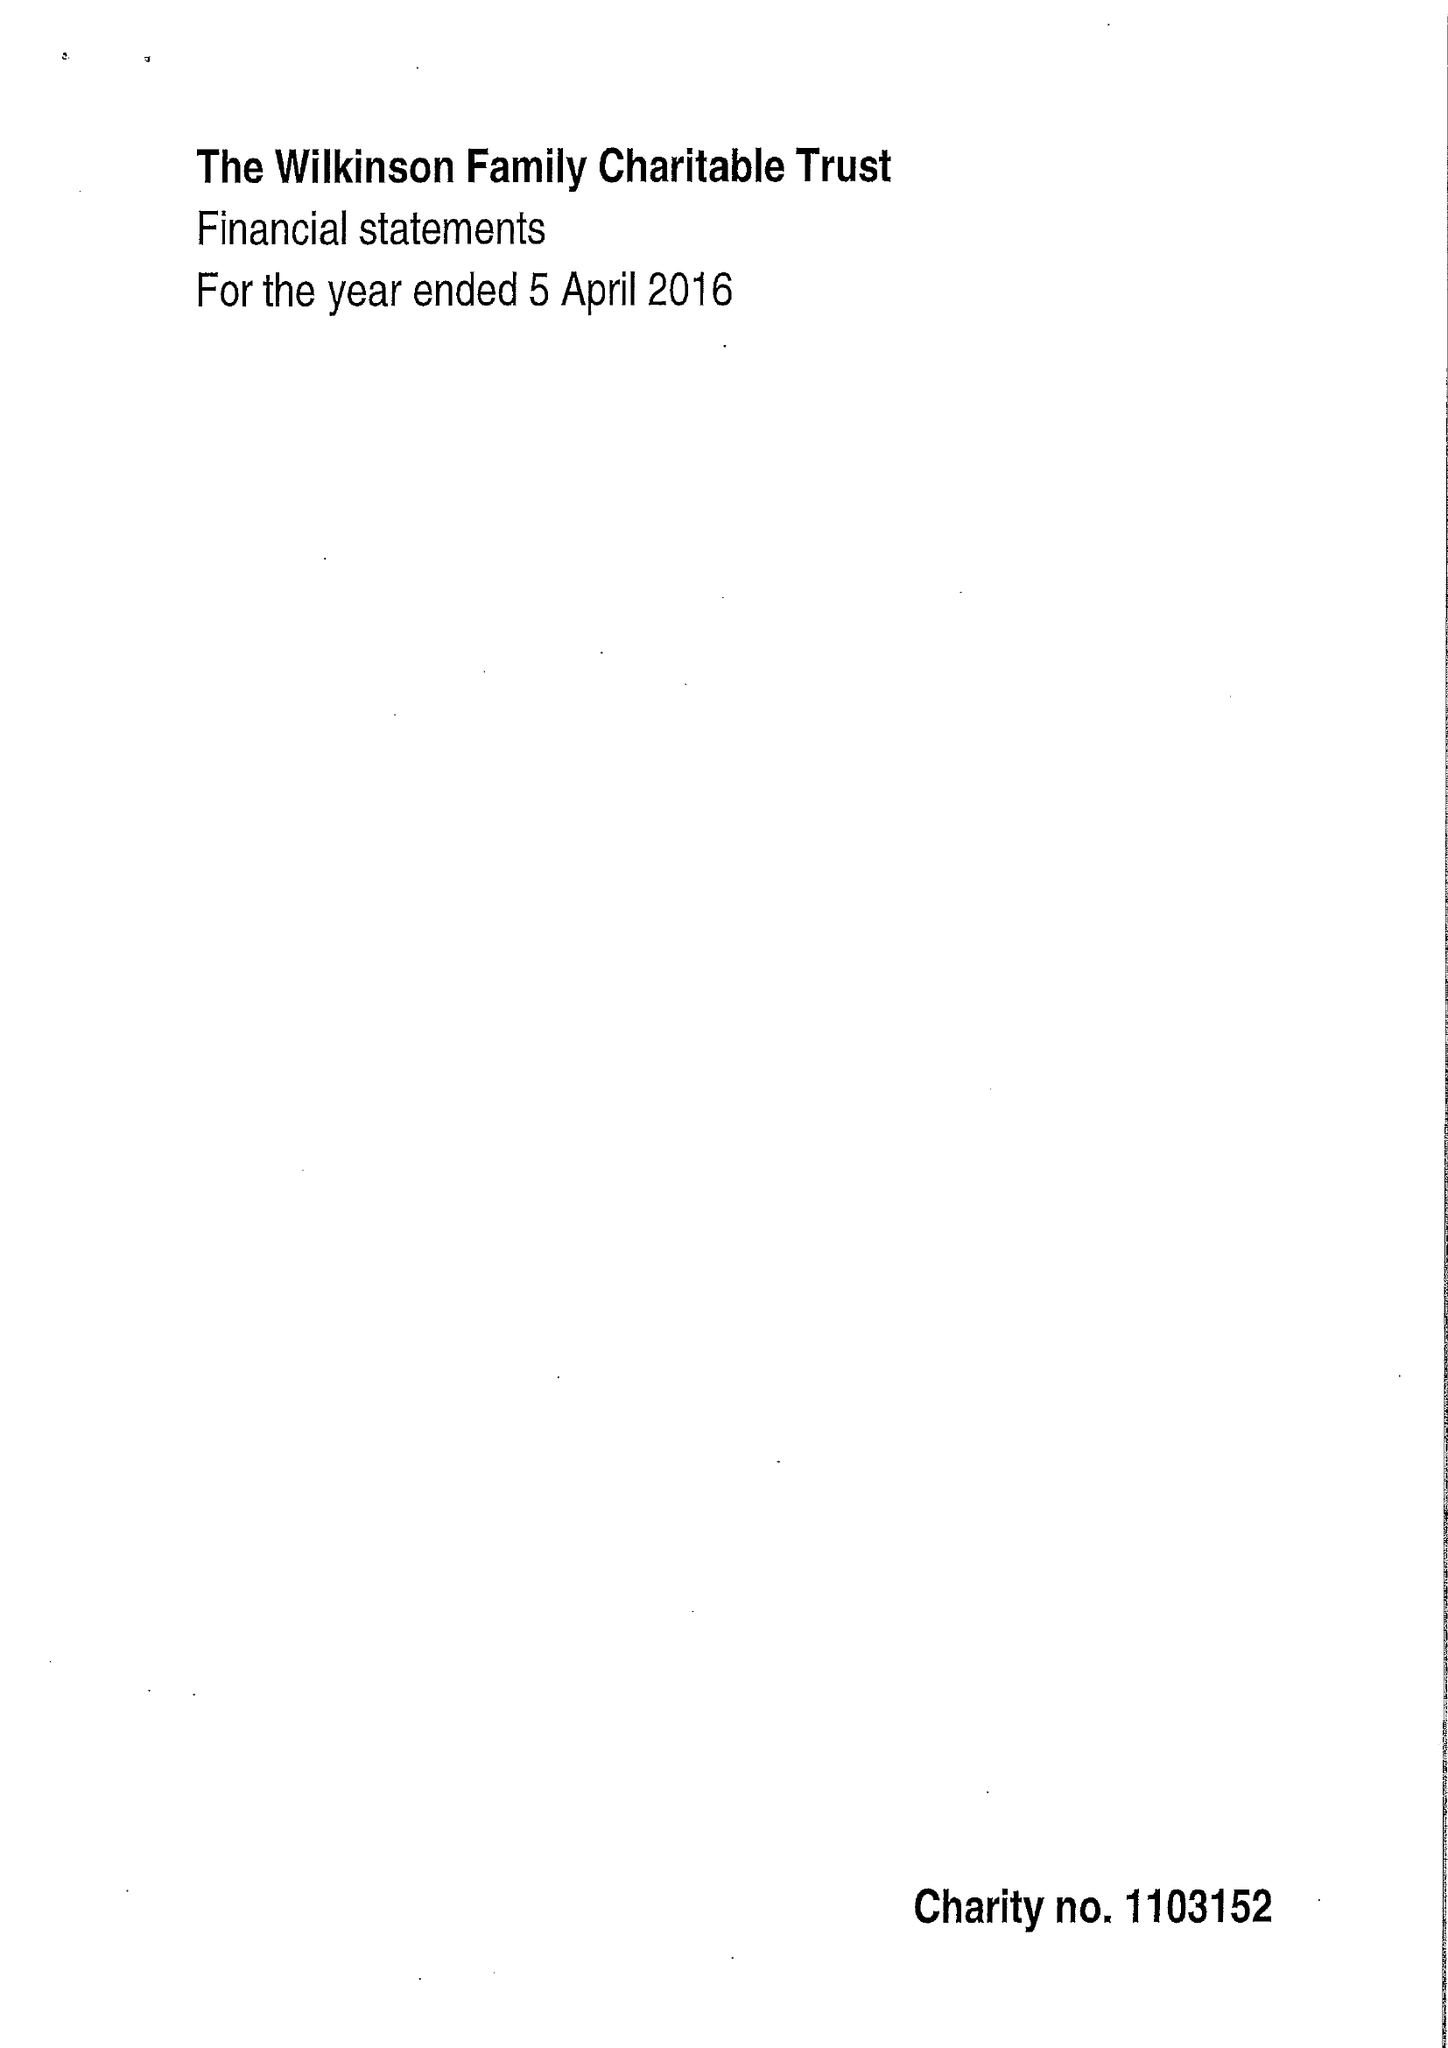What is the value for the spending_annually_in_british_pounds?
Answer the question using a single word or phrase. 41522.00 